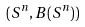<formula> <loc_0><loc_0><loc_500><loc_500>( S ^ { n } , B ( S ^ { n } ) )</formula> 